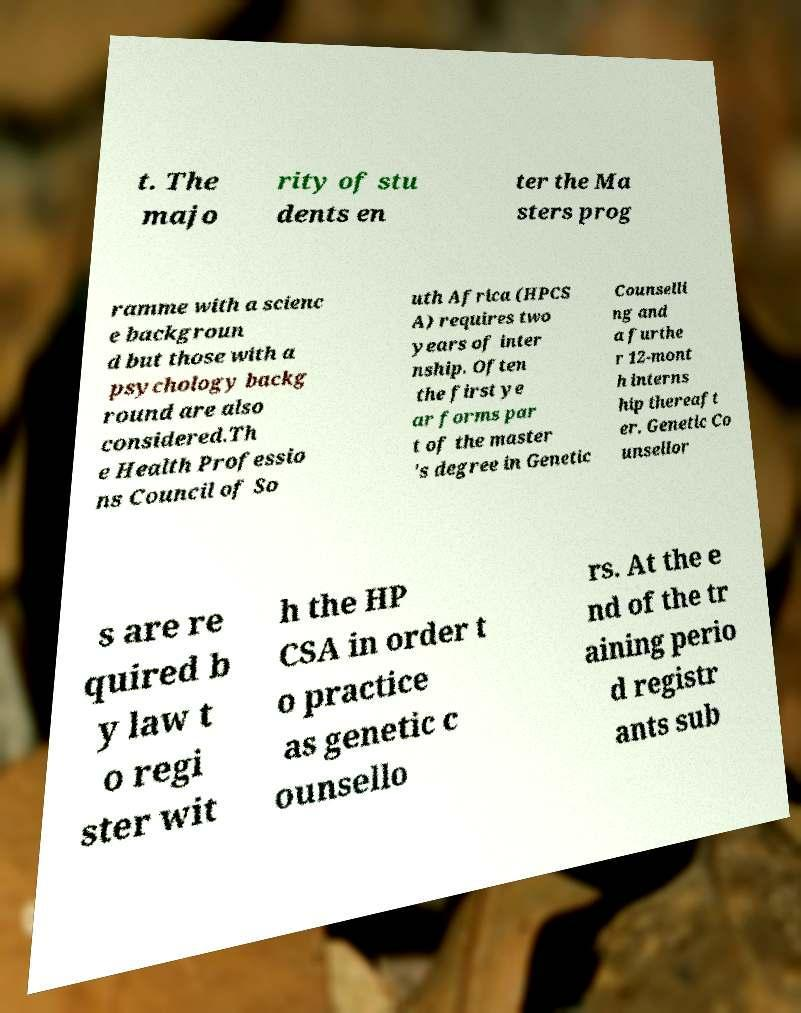There's text embedded in this image that I need extracted. Can you transcribe it verbatim? t. The majo rity of stu dents en ter the Ma sters prog ramme with a scienc e backgroun d but those with a psychology backg round are also considered.Th e Health Professio ns Council of So uth Africa (HPCS A) requires two years of inter nship. Often the first ye ar forms par t of the master 's degree in Genetic Counselli ng and a furthe r 12-mont h interns hip thereaft er. Genetic Co unsellor s are re quired b y law t o regi ster wit h the HP CSA in order t o practice as genetic c ounsello rs. At the e nd of the tr aining perio d registr ants sub 